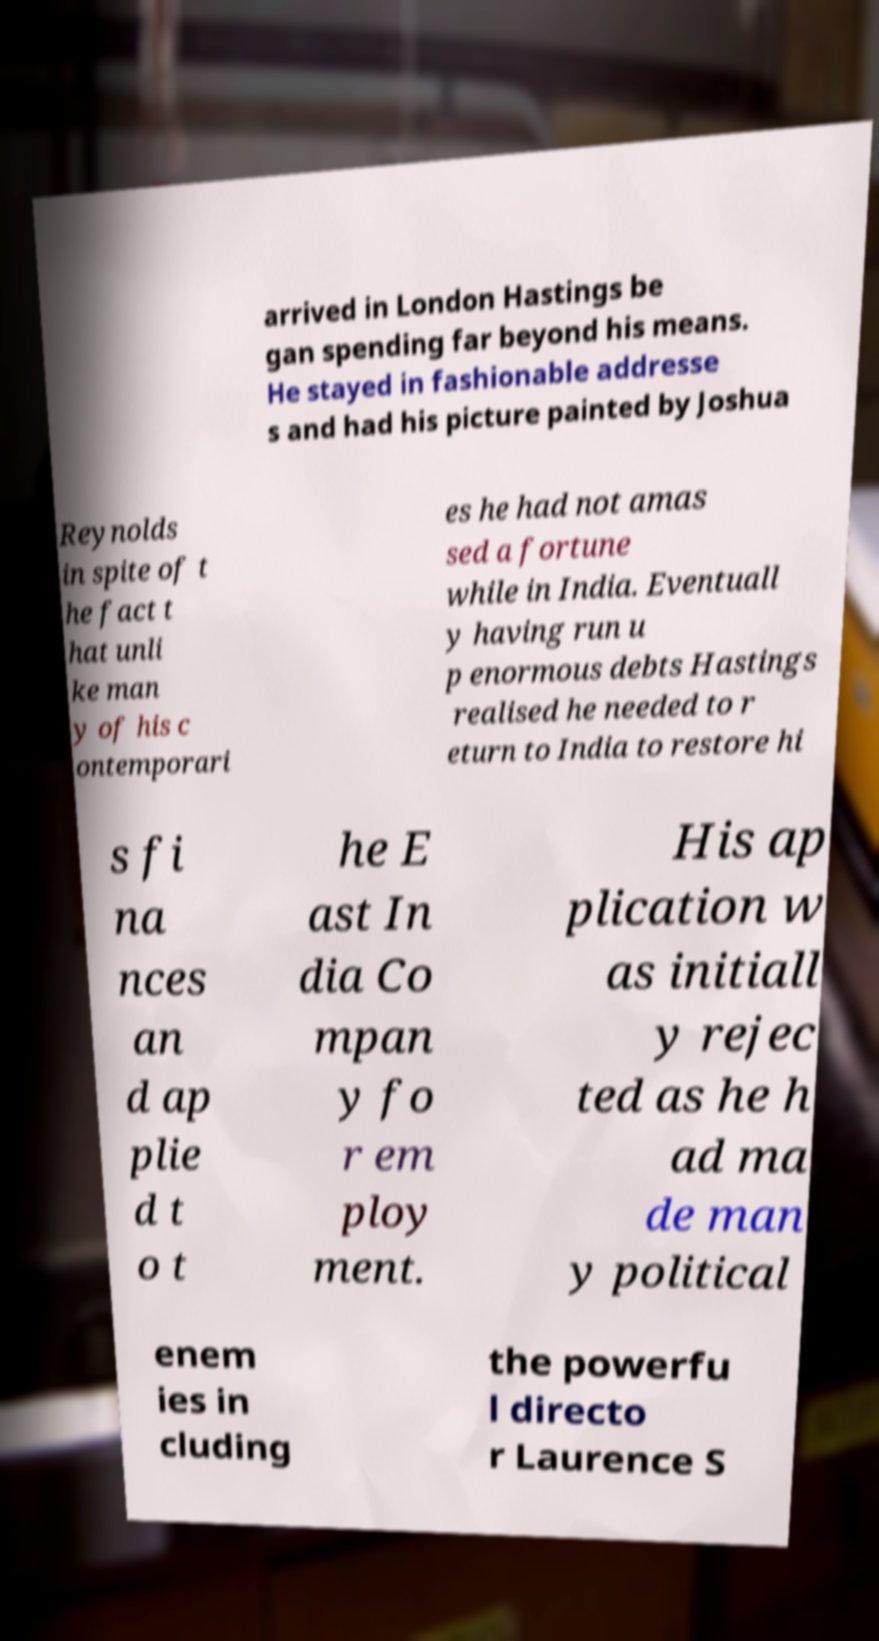Could you extract and type out the text from this image? arrived in London Hastings be gan spending far beyond his means. He stayed in fashionable addresse s and had his picture painted by Joshua Reynolds in spite of t he fact t hat unli ke man y of his c ontemporari es he had not amas sed a fortune while in India. Eventuall y having run u p enormous debts Hastings realised he needed to r eturn to India to restore hi s fi na nces an d ap plie d t o t he E ast In dia Co mpan y fo r em ploy ment. His ap plication w as initiall y rejec ted as he h ad ma de man y political enem ies in cluding the powerfu l directo r Laurence S 